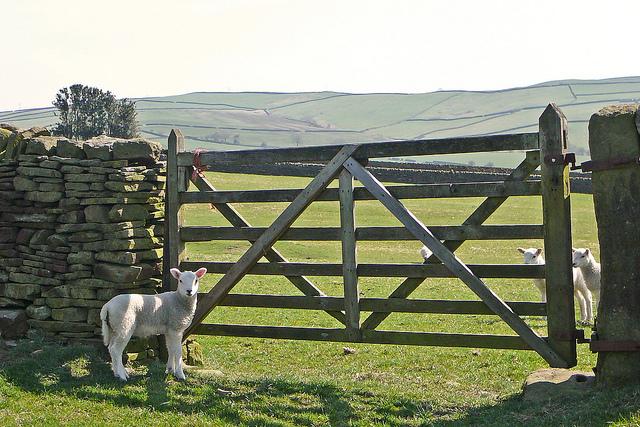How many horses are in the photo?
Concise answer only. 0. What number is on the horse?
Keep it brief. No horse. What is stacked up?
Answer briefly. Stones. What are the lines on the hill?
Concise answer only. Roads. Are shadows cast?
Keep it brief. Yes. What is the gate made of?
Answer briefly. Wood. 